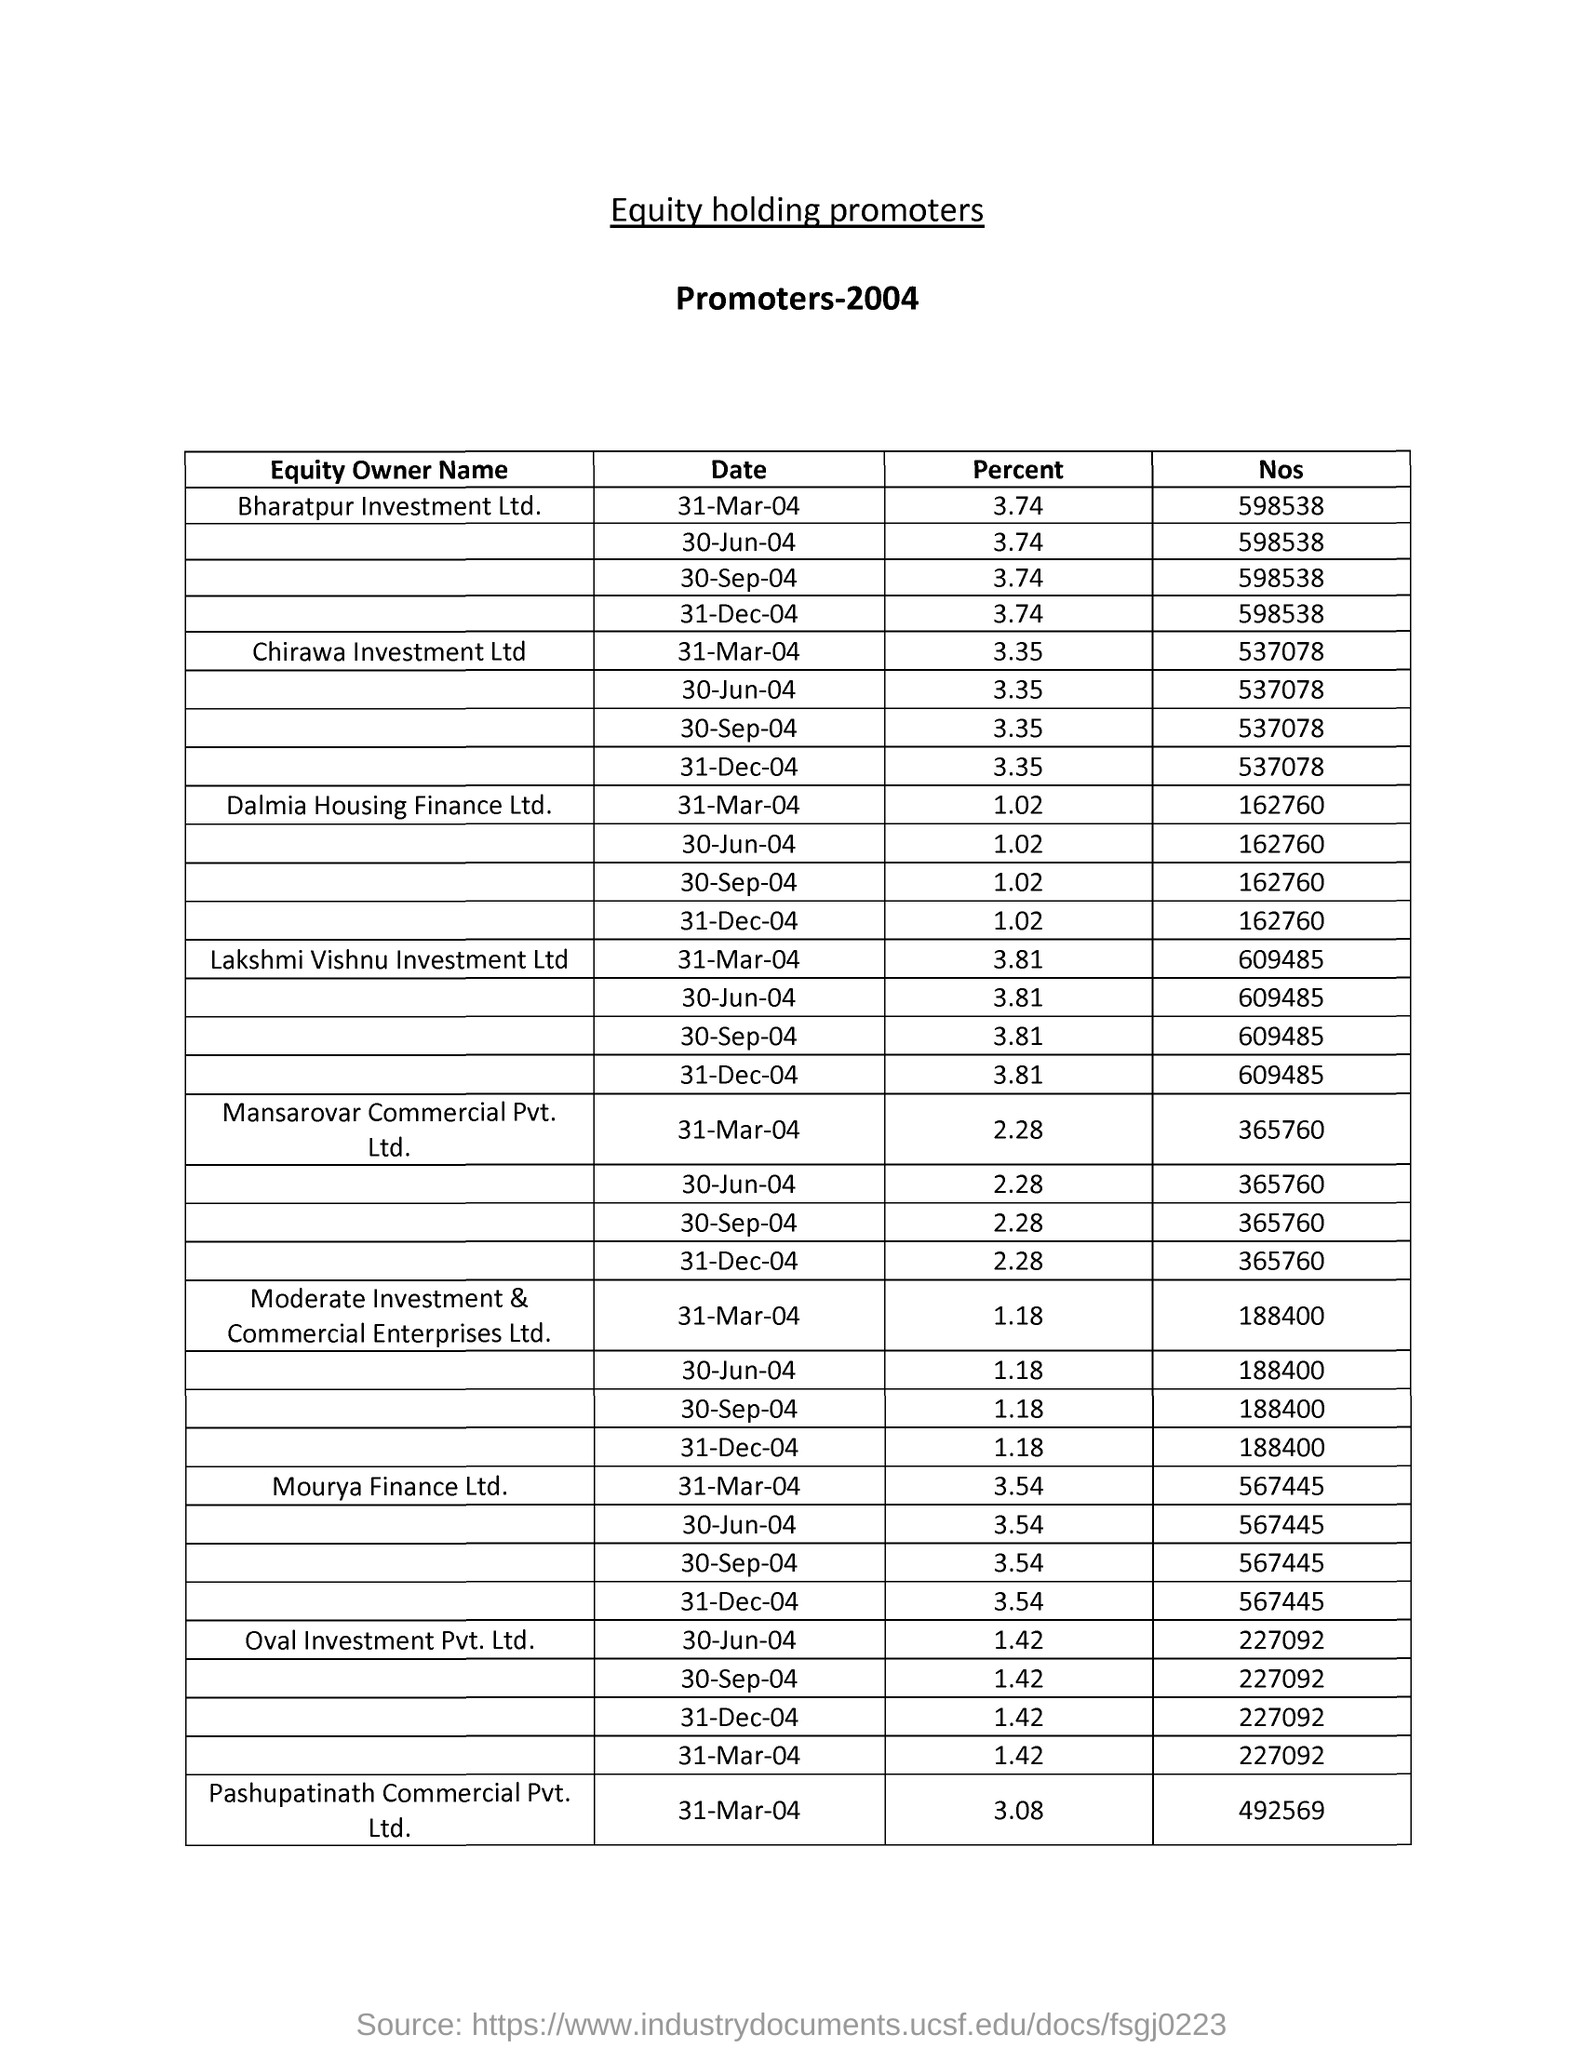Give some essential details in this illustration. The percent holdings of Bharatpur Investment Ltd. as of March 31, 2004 were 3.74%. The title of this document is 'What is the equity holding of promoters?' As of March 31, 2004, the number of equity holdings of Chirawa Investment Ltd was 537078. The data is from the year 2004. 